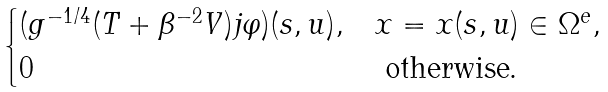Convert formula to latex. <formula><loc_0><loc_0><loc_500><loc_500>\begin{cases} ( g ^ { - 1 / 4 } ( T + \beta ^ { - 2 } V ) j \varphi ) ( s , u ) , & x = x ( s , u ) \in \Omega ^ { e } , \\ 0 & \text { otherwise.} \end{cases}</formula> 